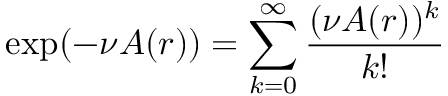Convert formula to latex. <formula><loc_0><loc_0><loc_500><loc_500>\exp ( - \nu A ( r ) ) = \sum _ { k = 0 } ^ { \infty } \frac { ( \nu A ( r ) ) ^ { k } } { k ! }</formula> 